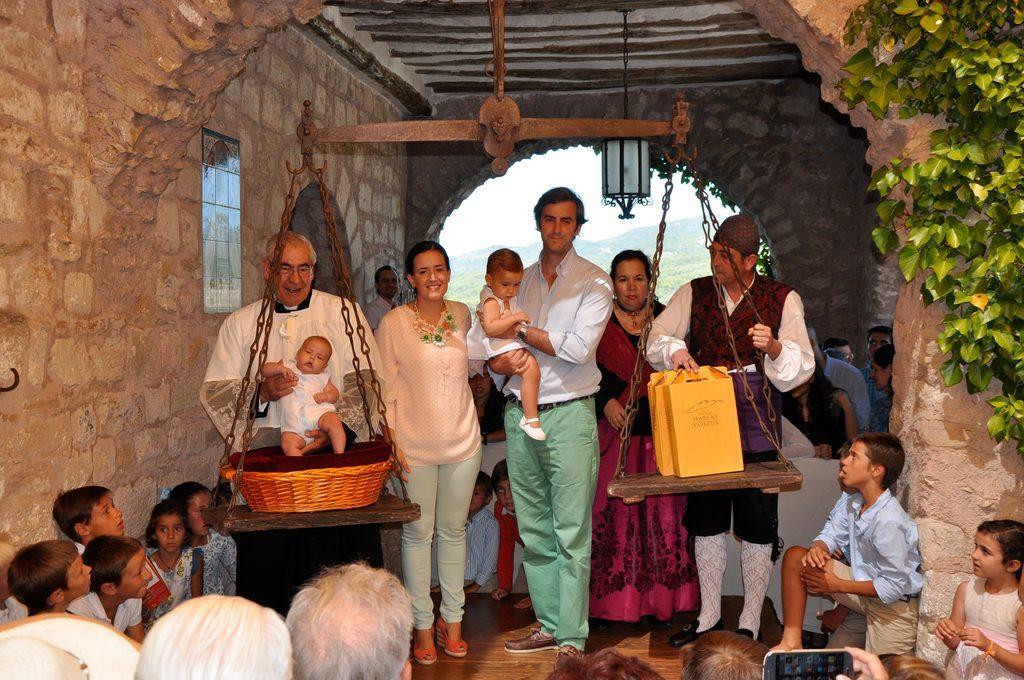Could you give a brief overview of what you see in this image? In this image I can see group of people standing, in front I can see weighing machine, I can also see plants in green color and sky in white color. 